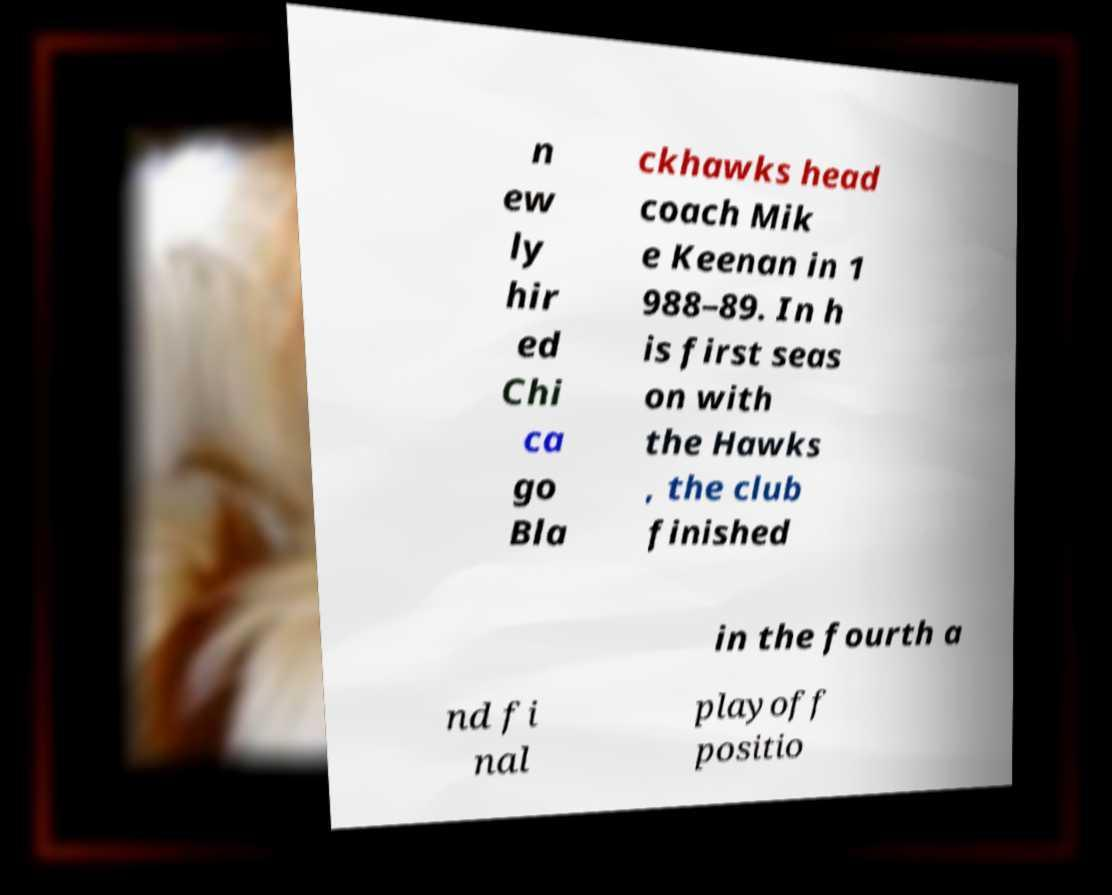Can you read and provide the text displayed in the image?This photo seems to have some interesting text. Can you extract and type it out for me? n ew ly hir ed Chi ca go Bla ckhawks head coach Mik e Keenan in 1 988–89. In h is first seas on with the Hawks , the club finished in the fourth a nd fi nal playoff positio 